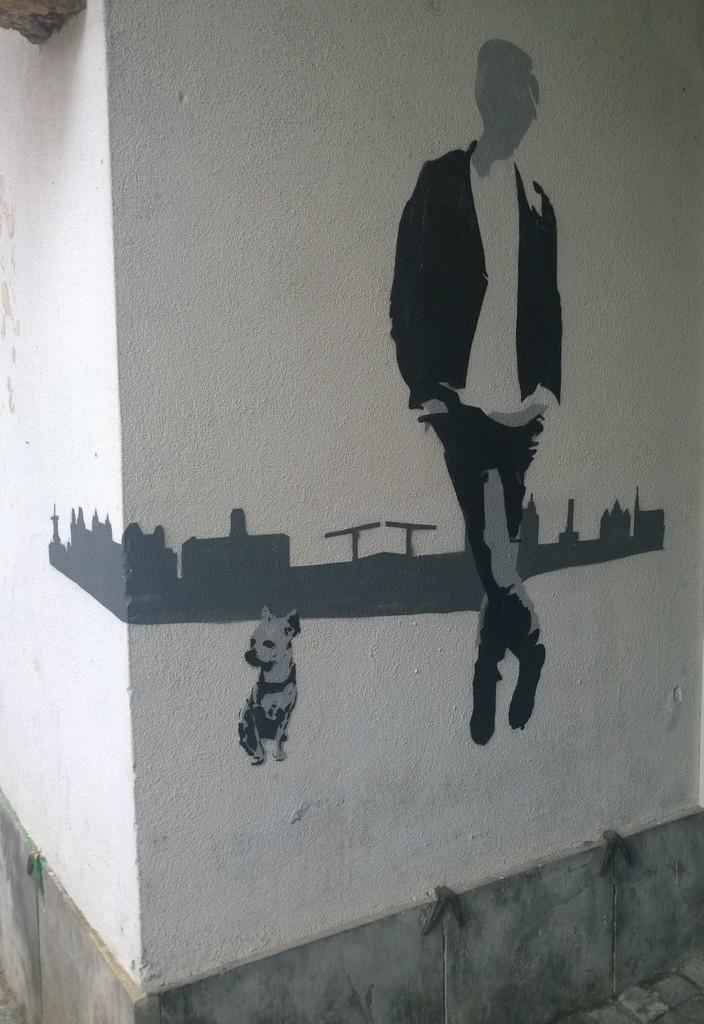What is on the wall in the image? There is a painting on the wall in the image. What type of farm animals can be seen in the painting on the wall? There is no information about the content of the painting, so we cannot determine if there are any farm animals present. 